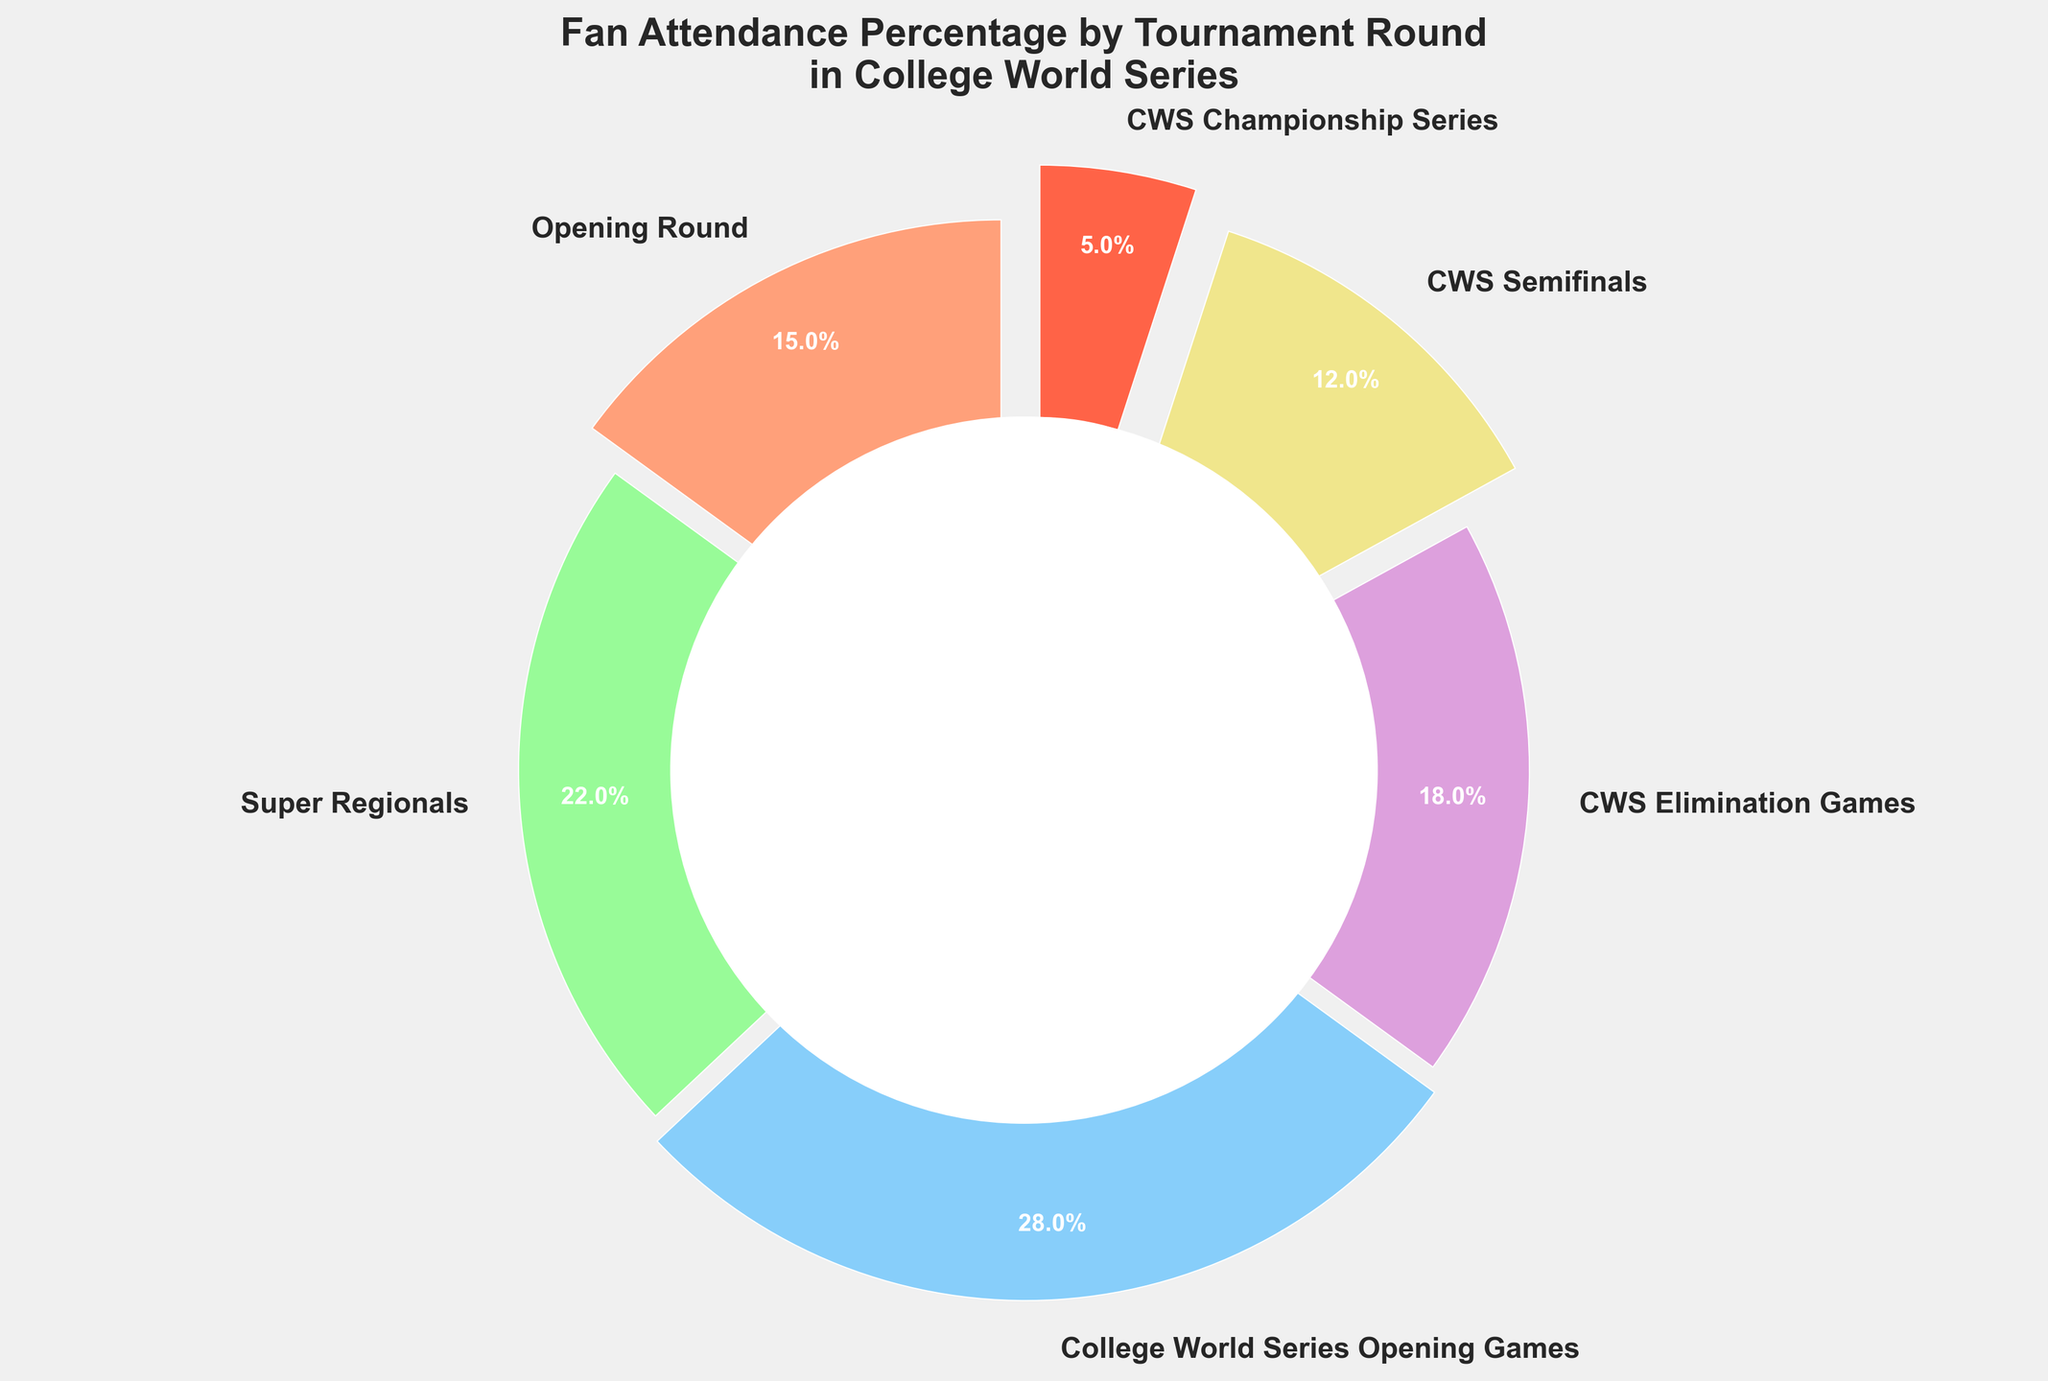Which round has the highest fan attendance percentage? The slice labeled "College World Series Opening Games" has the highest percentage, occupying the largest portion of the pie chart.
Answer: College World Series Opening Games Which rounds have a combined attendance percentage greater than 50%? By visually adding the percentages of the slices labeled "Opening Round" (15%), "Super Regionals" (22%), and "College World Series Opening Games" (28%), the combined value is 15% + 22% + 28% = 65%, which is greater than 50%.
Answer: Opening Round, Super Regionals, College World Series Opening Games What is the smallest fan attendance percentage, and which round does it correspond to? The smallest slice of the pie chart corresponds to the "CWS Championship Series" with a value of 5%.
Answer: CWS Championship Series, 5% What is the difference in attendance percentages between the "CWS Elimination Games" and the "CWS Semifinals"? The slice for "CWS Elimination Games" is 18% and for "CWS Semifinals" is 12%. The difference is 18% - 12% = 6%.
Answer: 6% Which round has a fan attendance percentage of 12%? The slice labeled "CWS Semifinals" shows a fan attendance percentage of 12%.
Answer: CWS Semifinals If we combine the attendance percentages of "Opening Round" and "Super Regionals," which rounds have an equal or higher attendance percentage? The attendance percentages for "Opening Round" and "Super Regionals" add up to 15% + 22% = 37%. Comparing this with other rounds, "College World Series Opening Games" (28%) is less and "CWS Elimination Games" (18%), "CWS Semifinals" (12%), and "CWS Championship Series" (5%) are all less.
Answer: None 